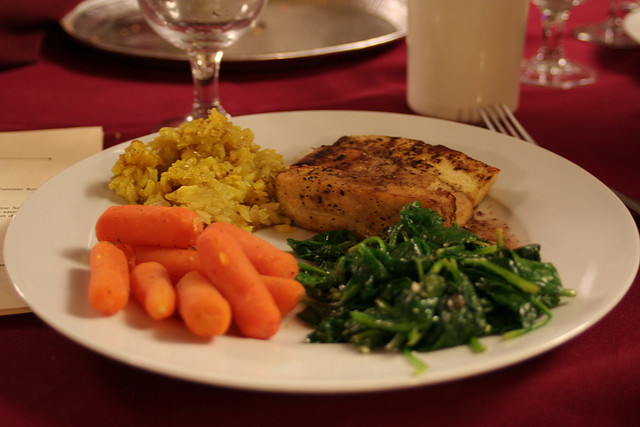<image>What type of wine is there? The type of wine is ambiguous. There might be white wine, or there might be no wine at all. What type of wine is there? I am not sure what type of wine is there. However, it seems like it can be white wine. 